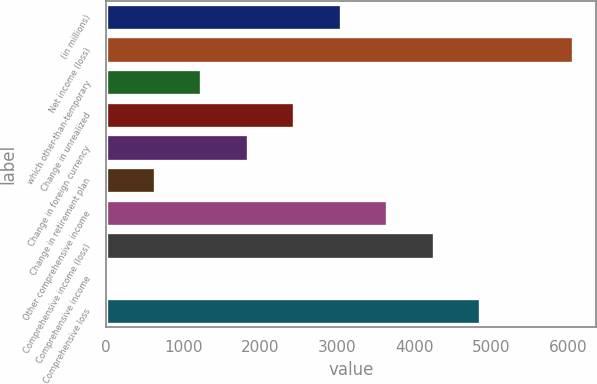<chart> <loc_0><loc_0><loc_500><loc_500><bar_chart><fcel>(in millions)<fcel>Net income (loss)<fcel>which other-than-temporary<fcel>Change in unrealized<fcel>Change in foreign currency<fcel>Change in retirement plan<fcel>Other comprehensive income<fcel>Comprehensive income (loss)<fcel>Comprehensive income<fcel>Comprehensive loss<nl><fcel>3042<fcel>6056<fcel>1233.6<fcel>2439.2<fcel>1836.4<fcel>630.8<fcel>3644.8<fcel>4247.6<fcel>28<fcel>4850.4<nl></chart> 